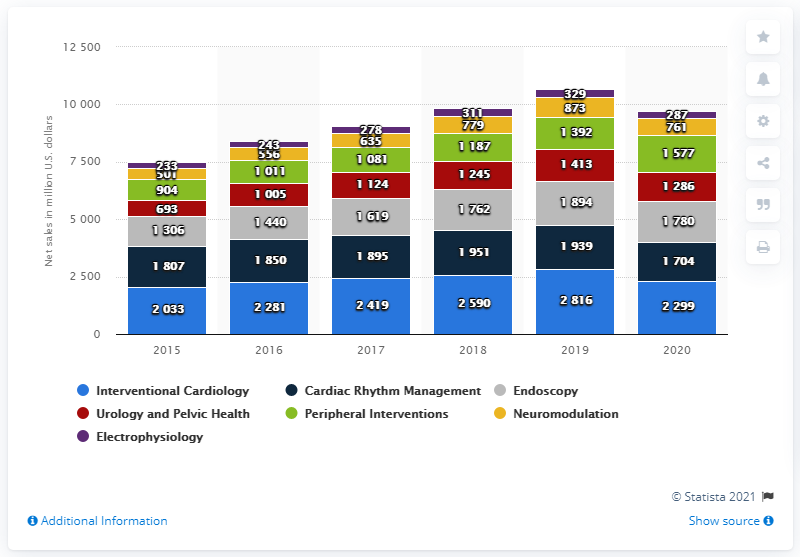List a handful of essential elements in this visual. In the United States in 2020, Interventional Cardiology products generated approximately 2,281 million dollars in revenue. During the entire period, Interventional Cardiology was the top-selling product category. 